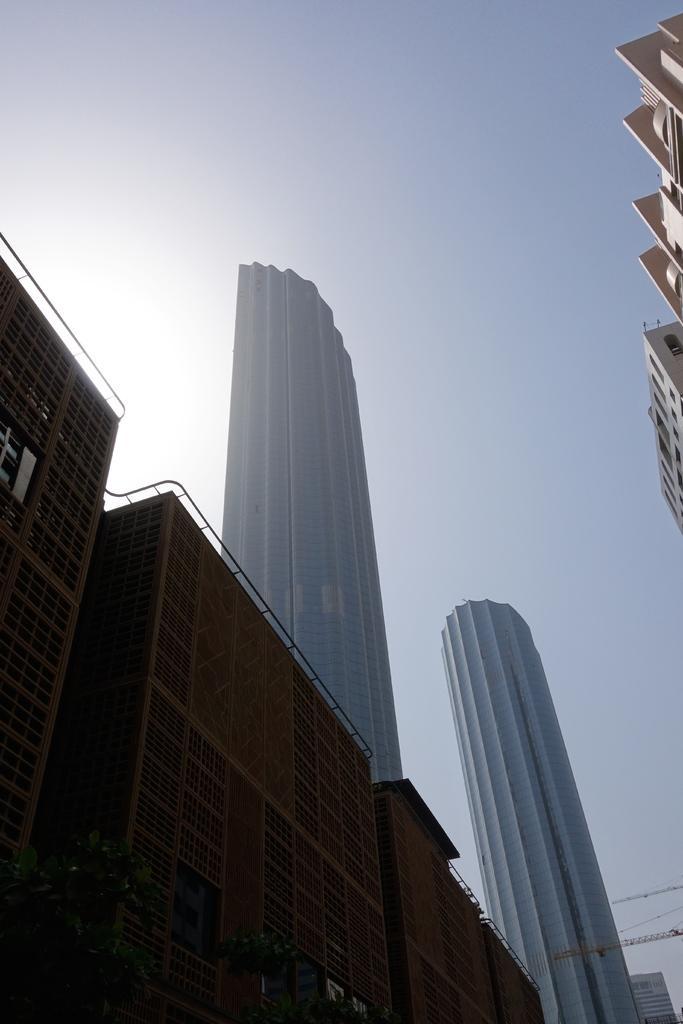In one or two sentences, can you explain what this image depicts? In this image we can see buildings, at above the sky is in blue color. 